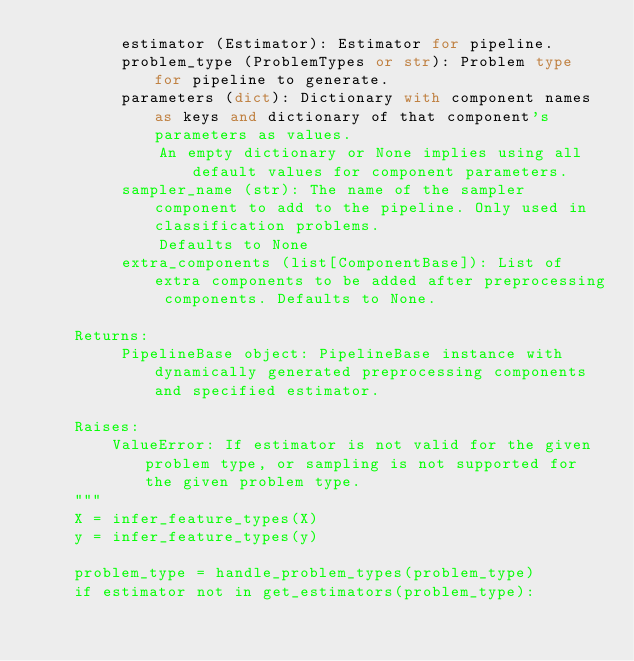<code> <loc_0><loc_0><loc_500><loc_500><_Python_>         estimator (Estimator): Estimator for pipeline.
         problem_type (ProblemTypes or str): Problem type for pipeline to generate.
         parameters (dict): Dictionary with component names as keys and dictionary of that component's parameters as values.
             An empty dictionary or None implies using all default values for component parameters.
         sampler_name (str): The name of the sampler component to add to the pipeline. Only used in classification problems.
             Defaults to None
         extra_components (list[ComponentBase]): List of extra components to be added after preprocessing components. Defaults to None.

    Returns:
         PipelineBase object: PipelineBase instance with dynamically generated preprocessing components and specified estimator.

    Raises:
        ValueError: If estimator is not valid for the given problem type, or sampling is not supported for the given problem type.
    """
    X = infer_feature_types(X)
    y = infer_feature_types(y)

    problem_type = handle_problem_types(problem_type)
    if estimator not in get_estimators(problem_type):</code> 